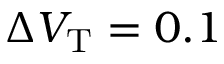<formula> <loc_0><loc_0><loc_500><loc_500>\Delta V _ { T } = 0 . 1</formula> 